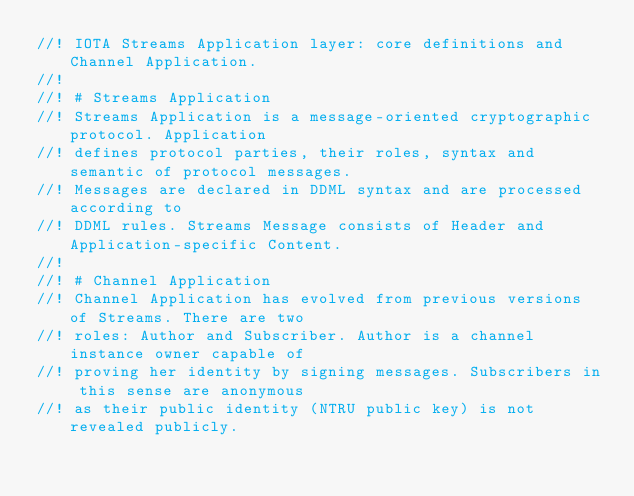Convert code to text. <code><loc_0><loc_0><loc_500><loc_500><_Rust_>//! IOTA Streams Application layer: core definitions and Channel Application.
//!
//! # Streams Application
//! Streams Application is a message-oriented cryptographic protocol. Application
//! defines protocol parties, their roles, syntax and semantic of protocol messages.
//! Messages are declared in DDML syntax and are processed according to
//! DDML rules. Streams Message consists of Header and Application-specific Content.
//!
//! # Channel Application
//! Channel Application has evolved from previous versions of Streams. There are two
//! roles: Author and Subscriber. Author is a channel instance owner capable of
//! proving her identity by signing messages. Subscribers in this sense are anonymous
//! as their public identity (NTRU public key) is not revealed publicly.</code> 